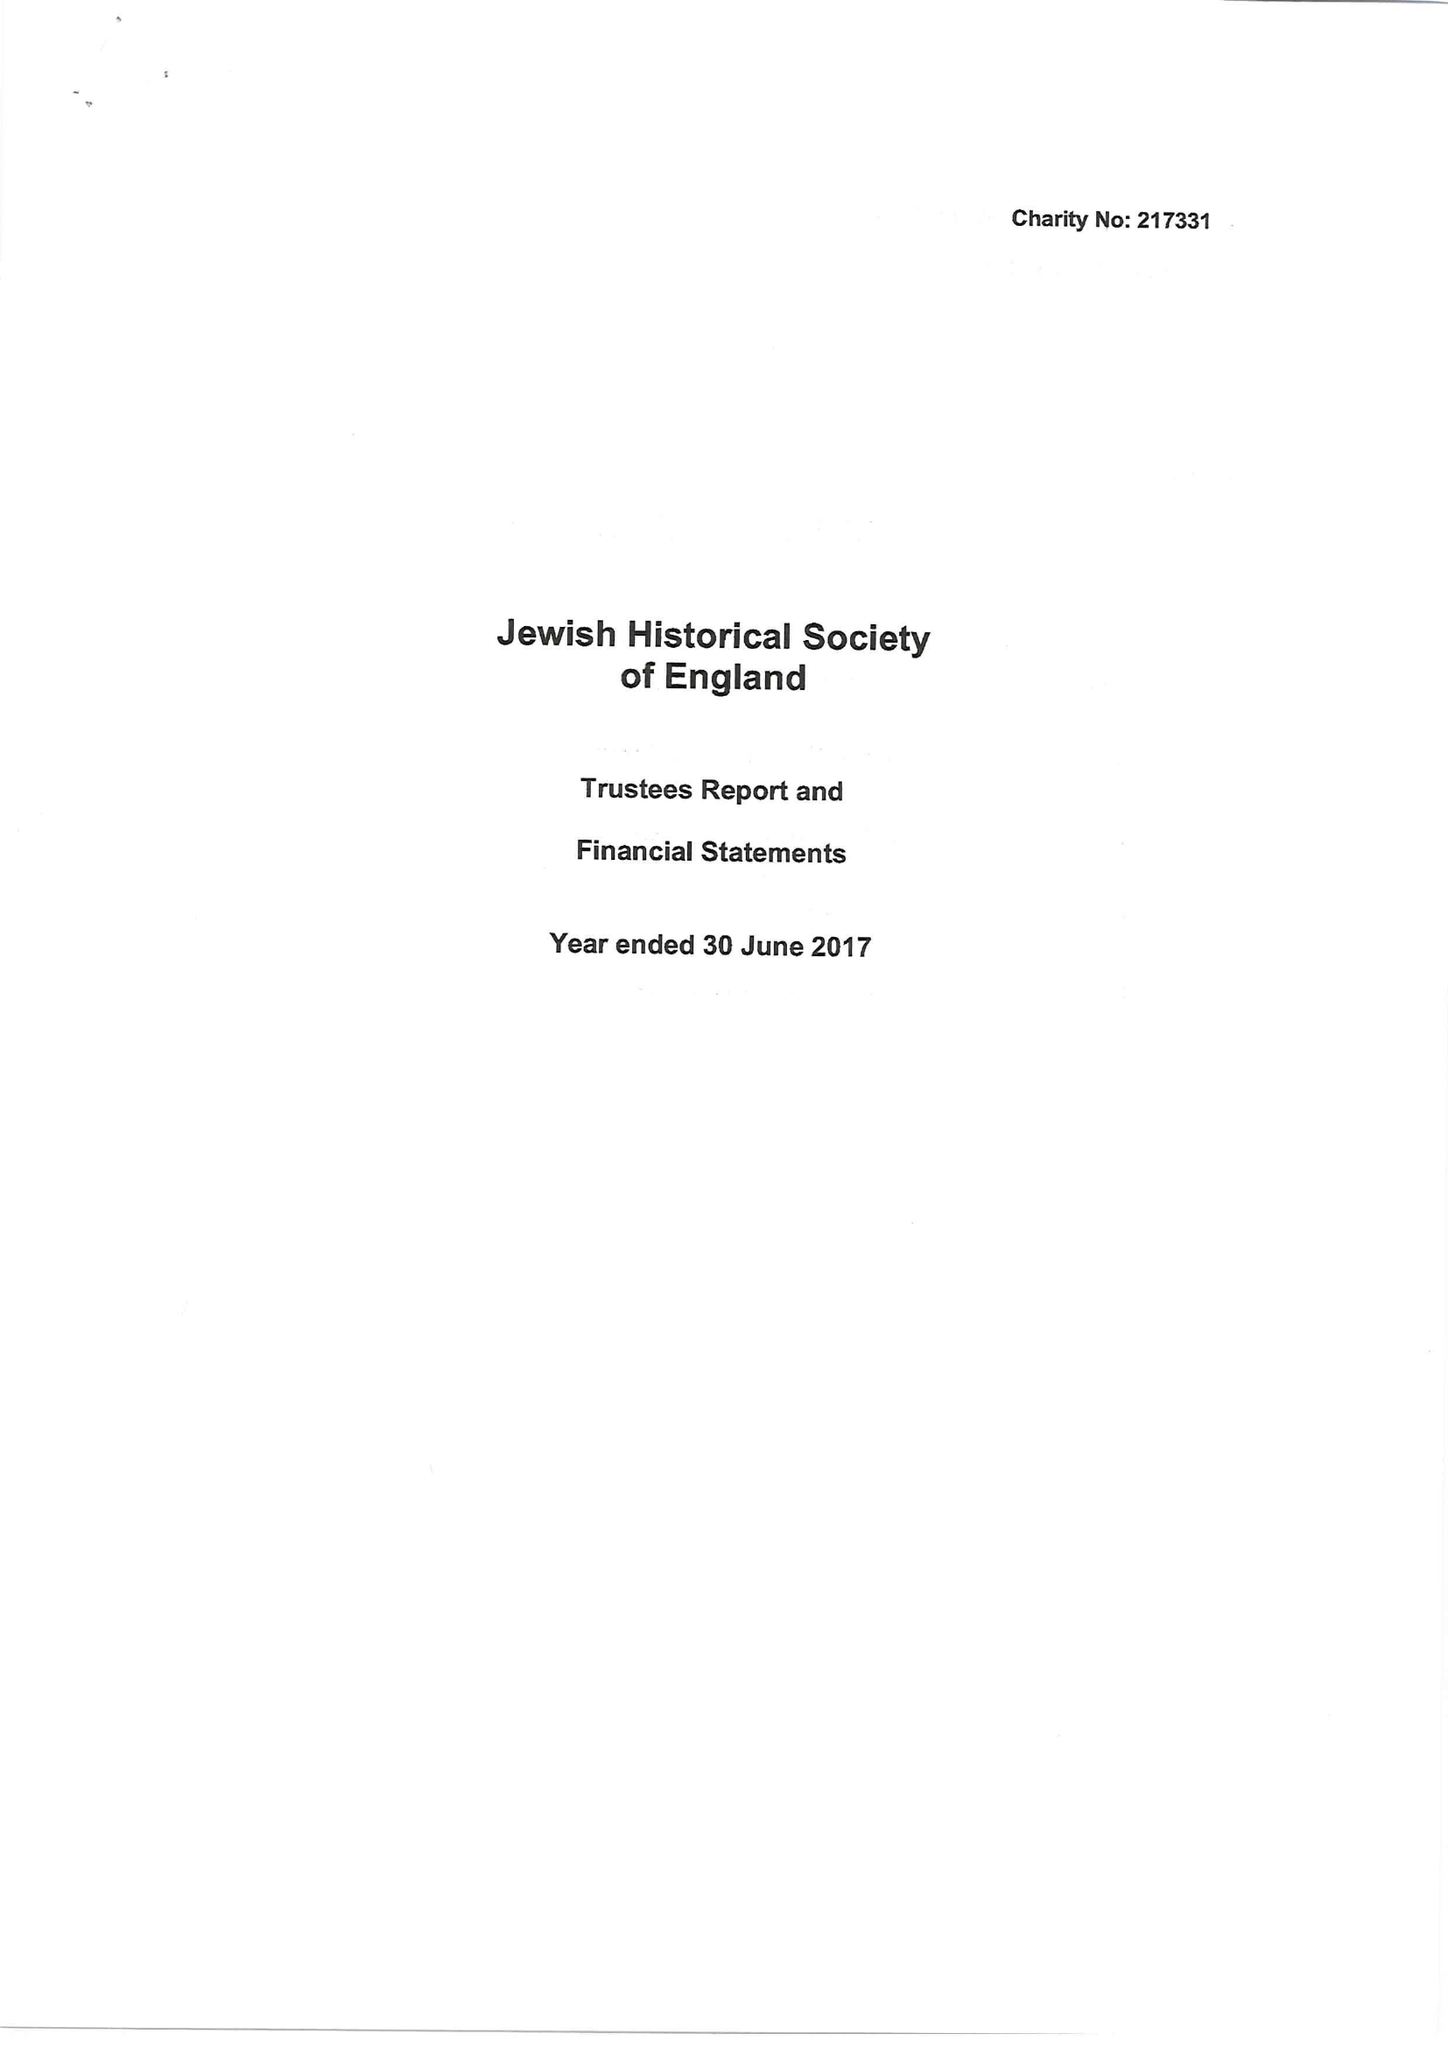What is the value for the charity_name?
Answer the question using a single word or phrase. Jewish Historical Society Of England 